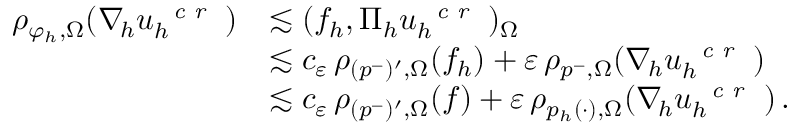Convert formula to latex. <formula><loc_0><loc_0><loc_500><loc_500>\begin{array} { r l } { \rho _ { \varphi _ { h } , \Omega } ( \nabla _ { \, h } u _ { h } ^ { c r } ) } & { \lesssim ( f _ { h } , \Pi _ { h } u _ { h } ^ { c r } ) _ { \Omega } } \\ & { \lesssim c _ { \varepsilon } \, \rho _ { ( p ^ { - } ) ^ { \prime } , \Omega } ( f _ { h } ) + \varepsilon \, \rho _ { p ^ { - } , \Omega } ( \nabla _ { \, h } u _ { h } ^ { c r } ) } \\ & { \lesssim c _ { \varepsilon } \, \rho _ { ( p ^ { - } ) ^ { \prime } , \Omega } ( f ) + \varepsilon \, \rho _ { p _ { h } ( \cdot ) , \Omega } ( \nabla _ { \, h } u _ { h } ^ { c r } ) \, . } \end{array}</formula> 